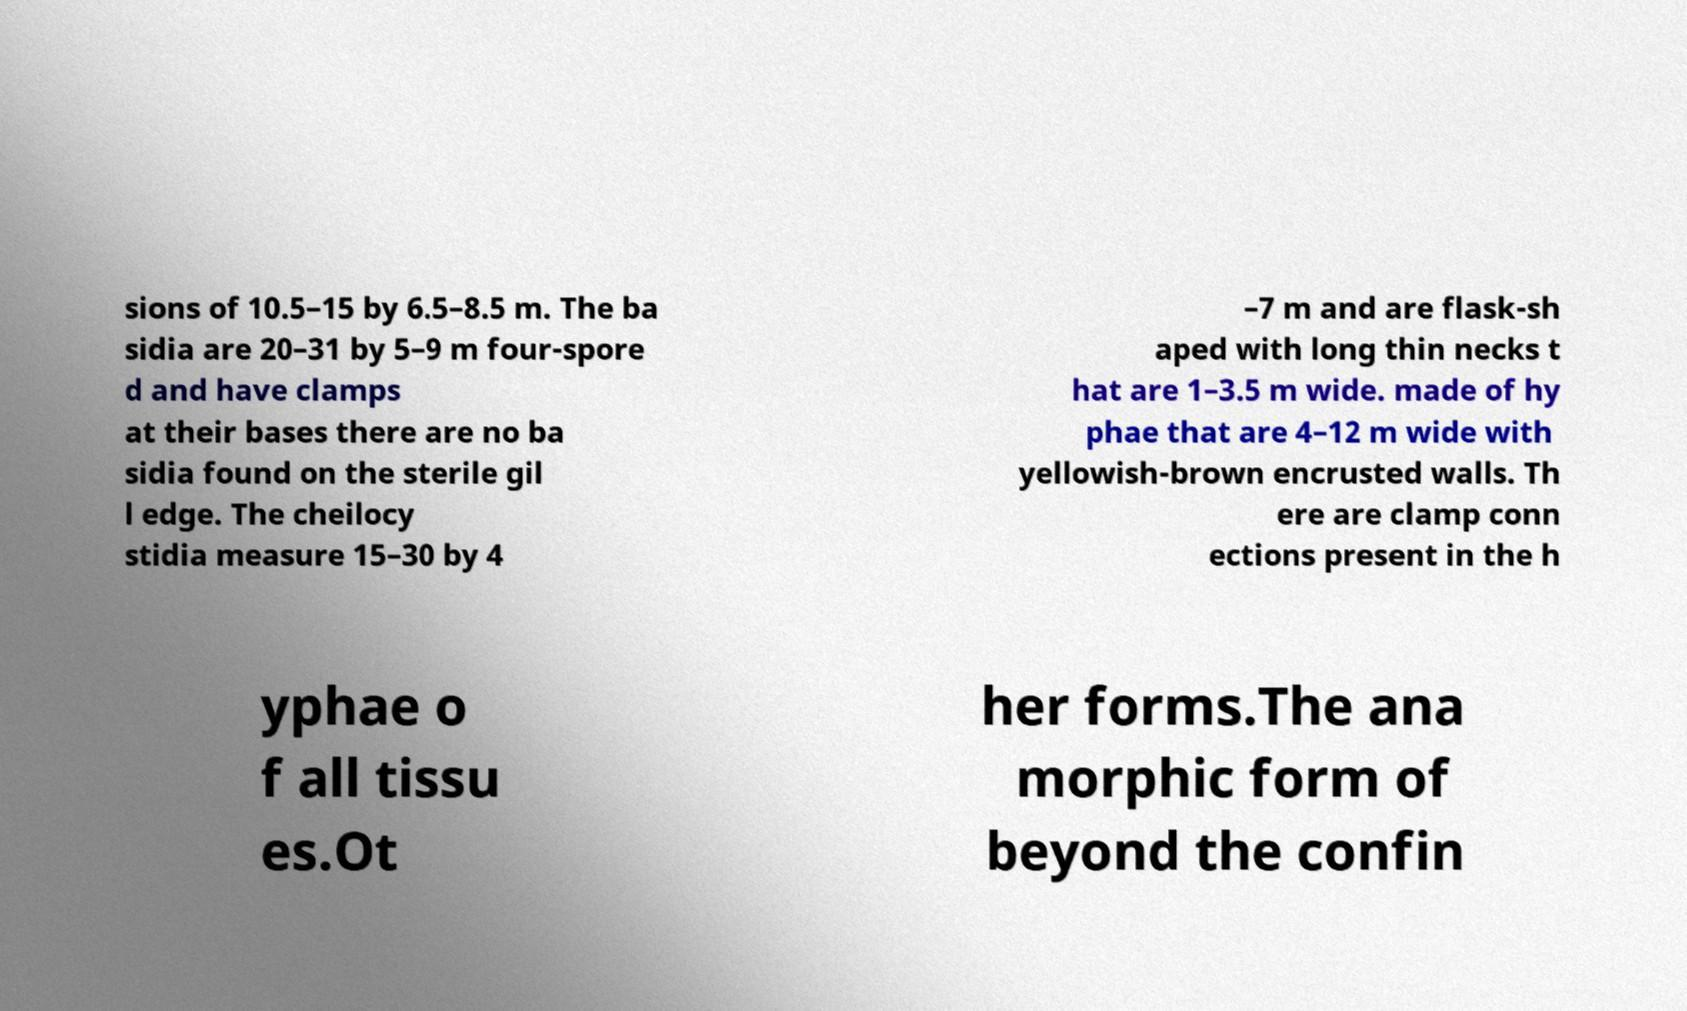Can you read and provide the text displayed in the image?This photo seems to have some interesting text. Can you extract and type it out for me? sions of 10.5–15 by 6.5–8.5 m. The ba sidia are 20–31 by 5–9 m four-spore d and have clamps at their bases there are no ba sidia found on the sterile gil l edge. The cheilocy stidia measure 15–30 by 4 –7 m and are flask-sh aped with long thin necks t hat are 1–3.5 m wide. made of hy phae that are 4–12 m wide with yellowish-brown encrusted walls. Th ere are clamp conn ections present in the h yphae o f all tissu es.Ot her forms.The ana morphic form of beyond the confin 